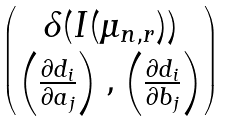Convert formula to latex. <formula><loc_0><loc_0><loc_500><loc_500>\begin{pmatrix} \delta ( I ( \mu _ { n , r } ) ) \\ \left ( \frac { \partial d _ { i } } { \partial a _ { j } } \right ) , \left ( \frac { \partial d _ { i } } { \partial b _ { j } } \right ) \end{pmatrix}</formula> 